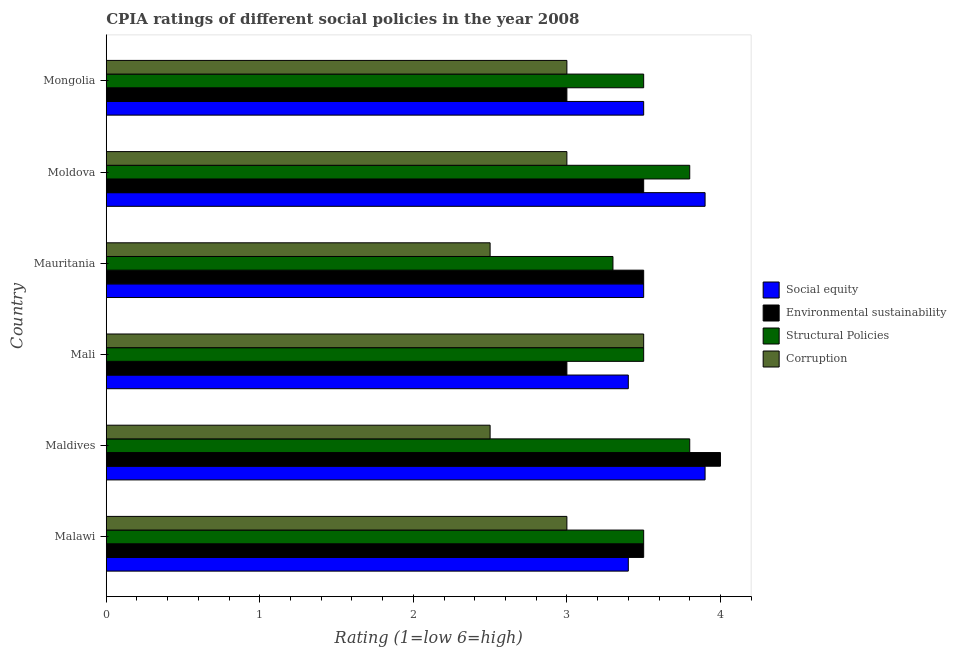How many groups of bars are there?
Provide a succinct answer. 6. Are the number of bars per tick equal to the number of legend labels?
Make the answer very short. Yes. Are the number of bars on each tick of the Y-axis equal?
Offer a very short reply. Yes. How many bars are there on the 4th tick from the top?
Provide a short and direct response. 4. How many bars are there on the 2nd tick from the bottom?
Offer a very short reply. 4. What is the label of the 6th group of bars from the top?
Provide a succinct answer. Malawi. In how many cases, is the number of bars for a given country not equal to the number of legend labels?
Make the answer very short. 0. What is the cpia rating of environmental sustainability in Malawi?
Your answer should be compact. 3.5. Across all countries, what is the maximum cpia rating of environmental sustainability?
Your response must be concise. 4. In which country was the cpia rating of structural policies maximum?
Provide a short and direct response. Maldives. In which country was the cpia rating of corruption minimum?
Your answer should be very brief. Maldives. What is the difference between the cpia rating of social equity in Mongolia and the cpia rating of environmental sustainability in Mali?
Make the answer very short. 0.5. What is the average cpia rating of structural policies per country?
Provide a short and direct response. 3.57. Is the difference between the cpia rating of social equity in Maldives and Mongolia greater than the difference between the cpia rating of environmental sustainability in Maldives and Mongolia?
Keep it short and to the point. No. What is the difference between the highest and the lowest cpia rating of environmental sustainability?
Give a very brief answer. 1. What does the 4th bar from the top in Moldova represents?
Your answer should be compact. Social equity. What does the 3rd bar from the bottom in Mongolia represents?
Keep it short and to the point. Structural Policies. How many bars are there?
Keep it short and to the point. 24. How many countries are there in the graph?
Make the answer very short. 6. Are the values on the major ticks of X-axis written in scientific E-notation?
Make the answer very short. No. Does the graph contain grids?
Ensure brevity in your answer.  No. How many legend labels are there?
Offer a terse response. 4. What is the title of the graph?
Make the answer very short. CPIA ratings of different social policies in the year 2008. Does "Gender equality" appear as one of the legend labels in the graph?
Provide a succinct answer. No. What is the Rating (1=low 6=high) in Environmental sustainability in Malawi?
Make the answer very short. 3.5. What is the Rating (1=low 6=high) of Social equity in Maldives?
Your response must be concise. 3.9. What is the Rating (1=low 6=high) in Environmental sustainability in Mauritania?
Your response must be concise. 3.5. What is the Rating (1=low 6=high) in Corruption in Mauritania?
Give a very brief answer. 2.5. What is the Rating (1=low 6=high) in Environmental sustainability in Moldova?
Make the answer very short. 3.5. What is the Rating (1=low 6=high) in Structural Policies in Moldova?
Ensure brevity in your answer.  3.8. What is the Rating (1=low 6=high) of Social equity in Mongolia?
Make the answer very short. 3.5. What is the Rating (1=low 6=high) in Environmental sustainability in Mongolia?
Keep it short and to the point. 3. What is the Rating (1=low 6=high) in Corruption in Mongolia?
Your answer should be very brief. 3. Across all countries, what is the maximum Rating (1=low 6=high) in Environmental sustainability?
Ensure brevity in your answer.  4. Across all countries, what is the maximum Rating (1=low 6=high) in Structural Policies?
Give a very brief answer. 3.8. Across all countries, what is the maximum Rating (1=low 6=high) of Corruption?
Keep it short and to the point. 3.5. Across all countries, what is the minimum Rating (1=low 6=high) in Social equity?
Offer a terse response. 3.4. What is the total Rating (1=low 6=high) in Social equity in the graph?
Ensure brevity in your answer.  21.6. What is the total Rating (1=low 6=high) in Structural Policies in the graph?
Your answer should be compact. 21.4. What is the difference between the Rating (1=low 6=high) in Social equity in Malawi and that in Maldives?
Provide a succinct answer. -0.5. What is the difference between the Rating (1=low 6=high) of Environmental sustainability in Malawi and that in Maldives?
Your answer should be very brief. -0.5. What is the difference between the Rating (1=low 6=high) of Structural Policies in Malawi and that in Maldives?
Provide a short and direct response. -0.3. What is the difference between the Rating (1=low 6=high) in Social equity in Malawi and that in Mali?
Offer a very short reply. 0. What is the difference between the Rating (1=low 6=high) of Environmental sustainability in Malawi and that in Mali?
Make the answer very short. 0.5. What is the difference between the Rating (1=low 6=high) of Structural Policies in Malawi and that in Mali?
Ensure brevity in your answer.  0. What is the difference between the Rating (1=low 6=high) of Corruption in Malawi and that in Mali?
Offer a very short reply. -0.5. What is the difference between the Rating (1=low 6=high) of Corruption in Malawi and that in Mauritania?
Offer a very short reply. 0.5. What is the difference between the Rating (1=low 6=high) of Social equity in Malawi and that in Moldova?
Provide a succinct answer. -0.5. What is the difference between the Rating (1=low 6=high) in Environmental sustainability in Malawi and that in Moldova?
Keep it short and to the point. 0. What is the difference between the Rating (1=low 6=high) in Structural Policies in Malawi and that in Moldova?
Offer a very short reply. -0.3. What is the difference between the Rating (1=low 6=high) of Social equity in Malawi and that in Mongolia?
Your response must be concise. -0.1. What is the difference between the Rating (1=low 6=high) in Corruption in Malawi and that in Mongolia?
Provide a short and direct response. 0. What is the difference between the Rating (1=low 6=high) in Social equity in Maldives and that in Mali?
Offer a terse response. 0.5. What is the difference between the Rating (1=low 6=high) in Environmental sustainability in Maldives and that in Mali?
Your answer should be very brief. 1. What is the difference between the Rating (1=low 6=high) in Corruption in Maldives and that in Mali?
Your response must be concise. -1. What is the difference between the Rating (1=low 6=high) in Social equity in Maldives and that in Mauritania?
Your answer should be compact. 0.4. What is the difference between the Rating (1=low 6=high) in Environmental sustainability in Maldives and that in Mauritania?
Keep it short and to the point. 0.5. What is the difference between the Rating (1=low 6=high) of Structural Policies in Maldives and that in Mauritania?
Make the answer very short. 0.5. What is the difference between the Rating (1=low 6=high) of Social equity in Maldives and that in Moldova?
Your answer should be very brief. 0. What is the difference between the Rating (1=low 6=high) of Environmental sustainability in Maldives and that in Moldova?
Your answer should be very brief. 0.5. What is the difference between the Rating (1=low 6=high) in Corruption in Maldives and that in Moldova?
Give a very brief answer. -0.5. What is the difference between the Rating (1=low 6=high) of Social equity in Maldives and that in Mongolia?
Give a very brief answer. 0.4. What is the difference between the Rating (1=low 6=high) in Corruption in Maldives and that in Mongolia?
Offer a very short reply. -0.5. What is the difference between the Rating (1=low 6=high) in Environmental sustainability in Mali and that in Mauritania?
Offer a very short reply. -0.5. What is the difference between the Rating (1=low 6=high) of Corruption in Mali and that in Mauritania?
Offer a terse response. 1. What is the difference between the Rating (1=low 6=high) of Social equity in Mali and that in Moldova?
Give a very brief answer. -0.5. What is the difference between the Rating (1=low 6=high) of Structural Policies in Mali and that in Moldova?
Make the answer very short. -0.3. What is the difference between the Rating (1=low 6=high) of Corruption in Mali and that in Moldova?
Your answer should be compact. 0.5. What is the difference between the Rating (1=low 6=high) of Environmental sustainability in Mali and that in Mongolia?
Offer a very short reply. 0. What is the difference between the Rating (1=low 6=high) in Structural Policies in Mali and that in Mongolia?
Make the answer very short. 0. What is the difference between the Rating (1=low 6=high) of Environmental sustainability in Mauritania and that in Moldova?
Your answer should be compact. 0. What is the difference between the Rating (1=low 6=high) of Social equity in Mauritania and that in Mongolia?
Provide a short and direct response. 0. What is the difference between the Rating (1=low 6=high) of Structural Policies in Mauritania and that in Mongolia?
Your response must be concise. -0.2. What is the difference between the Rating (1=low 6=high) in Corruption in Mauritania and that in Mongolia?
Your response must be concise. -0.5. What is the difference between the Rating (1=low 6=high) of Social equity in Moldova and that in Mongolia?
Offer a terse response. 0.4. What is the difference between the Rating (1=low 6=high) in Environmental sustainability in Moldova and that in Mongolia?
Keep it short and to the point. 0.5. What is the difference between the Rating (1=low 6=high) in Structural Policies in Moldova and that in Mongolia?
Provide a succinct answer. 0.3. What is the difference between the Rating (1=low 6=high) in Corruption in Moldova and that in Mongolia?
Ensure brevity in your answer.  0. What is the difference between the Rating (1=low 6=high) of Social equity in Malawi and the Rating (1=low 6=high) of Environmental sustainability in Maldives?
Make the answer very short. -0.6. What is the difference between the Rating (1=low 6=high) of Social equity in Malawi and the Rating (1=low 6=high) of Corruption in Maldives?
Offer a very short reply. 0.9. What is the difference between the Rating (1=low 6=high) in Environmental sustainability in Malawi and the Rating (1=low 6=high) in Structural Policies in Maldives?
Your answer should be compact. -0.3. What is the difference between the Rating (1=low 6=high) in Environmental sustainability in Malawi and the Rating (1=low 6=high) in Corruption in Maldives?
Your answer should be very brief. 1. What is the difference between the Rating (1=low 6=high) in Social equity in Malawi and the Rating (1=low 6=high) in Structural Policies in Mali?
Your answer should be very brief. -0.1. What is the difference between the Rating (1=low 6=high) of Social equity in Malawi and the Rating (1=low 6=high) of Corruption in Mali?
Your answer should be compact. -0.1. What is the difference between the Rating (1=low 6=high) of Environmental sustainability in Malawi and the Rating (1=low 6=high) of Corruption in Mali?
Make the answer very short. 0. What is the difference between the Rating (1=low 6=high) in Social equity in Malawi and the Rating (1=low 6=high) in Structural Policies in Mauritania?
Ensure brevity in your answer.  0.1. What is the difference between the Rating (1=low 6=high) in Environmental sustainability in Malawi and the Rating (1=low 6=high) in Corruption in Mauritania?
Make the answer very short. 1. What is the difference between the Rating (1=low 6=high) of Social equity in Malawi and the Rating (1=low 6=high) of Corruption in Moldova?
Give a very brief answer. 0.4. What is the difference between the Rating (1=low 6=high) of Structural Policies in Malawi and the Rating (1=low 6=high) of Corruption in Moldova?
Your response must be concise. 0.5. What is the difference between the Rating (1=low 6=high) in Social equity in Malawi and the Rating (1=low 6=high) in Corruption in Mongolia?
Keep it short and to the point. 0.4. What is the difference between the Rating (1=low 6=high) in Environmental sustainability in Malawi and the Rating (1=low 6=high) in Corruption in Mongolia?
Your answer should be very brief. 0.5. What is the difference between the Rating (1=low 6=high) in Social equity in Maldives and the Rating (1=low 6=high) in Environmental sustainability in Mali?
Make the answer very short. 0.9. What is the difference between the Rating (1=low 6=high) in Social equity in Maldives and the Rating (1=low 6=high) in Structural Policies in Mali?
Offer a terse response. 0.4. What is the difference between the Rating (1=low 6=high) of Environmental sustainability in Maldives and the Rating (1=low 6=high) of Structural Policies in Mali?
Your answer should be very brief. 0.5. What is the difference between the Rating (1=low 6=high) in Structural Policies in Maldives and the Rating (1=low 6=high) in Corruption in Mali?
Keep it short and to the point. 0.3. What is the difference between the Rating (1=low 6=high) in Environmental sustainability in Maldives and the Rating (1=low 6=high) in Corruption in Mauritania?
Your response must be concise. 1.5. What is the difference between the Rating (1=low 6=high) of Structural Policies in Maldives and the Rating (1=low 6=high) of Corruption in Mauritania?
Your answer should be very brief. 1.3. What is the difference between the Rating (1=low 6=high) in Social equity in Maldives and the Rating (1=low 6=high) in Environmental sustainability in Moldova?
Give a very brief answer. 0.4. What is the difference between the Rating (1=low 6=high) in Social equity in Maldives and the Rating (1=low 6=high) in Structural Policies in Moldova?
Offer a very short reply. 0.1. What is the difference between the Rating (1=low 6=high) in Environmental sustainability in Maldives and the Rating (1=low 6=high) in Structural Policies in Moldova?
Keep it short and to the point. 0.2. What is the difference between the Rating (1=low 6=high) of Environmental sustainability in Maldives and the Rating (1=low 6=high) of Corruption in Moldova?
Your answer should be very brief. 1. What is the difference between the Rating (1=low 6=high) of Social equity in Maldives and the Rating (1=low 6=high) of Environmental sustainability in Mongolia?
Your answer should be compact. 0.9. What is the difference between the Rating (1=low 6=high) in Environmental sustainability in Maldives and the Rating (1=low 6=high) in Structural Policies in Mongolia?
Keep it short and to the point. 0.5. What is the difference between the Rating (1=low 6=high) of Structural Policies in Maldives and the Rating (1=low 6=high) of Corruption in Mongolia?
Your answer should be compact. 0.8. What is the difference between the Rating (1=low 6=high) in Social equity in Mali and the Rating (1=low 6=high) in Environmental sustainability in Mauritania?
Offer a very short reply. -0.1. What is the difference between the Rating (1=low 6=high) in Social equity in Mali and the Rating (1=low 6=high) in Structural Policies in Mauritania?
Your response must be concise. 0.1. What is the difference between the Rating (1=low 6=high) of Environmental sustainability in Mali and the Rating (1=low 6=high) of Corruption in Mauritania?
Make the answer very short. 0.5. What is the difference between the Rating (1=low 6=high) in Structural Policies in Mali and the Rating (1=low 6=high) in Corruption in Mauritania?
Your answer should be very brief. 1. What is the difference between the Rating (1=low 6=high) of Social equity in Mali and the Rating (1=low 6=high) of Environmental sustainability in Moldova?
Keep it short and to the point. -0.1. What is the difference between the Rating (1=low 6=high) in Environmental sustainability in Mali and the Rating (1=low 6=high) in Corruption in Moldova?
Make the answer very short. 0. What is the difference between the Rating (1=low 6=high) in Structural Policies in Mali and the Rating (1=low 6=high) in Corruption in Moldova?
Your response must be concise. 0.5. What is the difference between the Rating (1=low 6=high) in Social equity in Mali and the Rating (1=low 6=high) in Environmental sustainability in Mongolia?
Provide a succinct answer. 0.4. What is the difference between the Rating (1=low 6=high) of Social equity in Mali and the Rating (1=low 6=high) of Structural Policies in Mongolia?
Ensure brevity in your answer.  -0.1. What is the difference between the Rating (1=low 6=high) in Environmental sustainability in Mali and the Rating (1=low 6=high) in Corruption in Mongolia?
Give a very brief answer. 0. What is the difference between the Rating (1=low 6=high) in Social equity in Mauritania and the Rating (1=low 6=high) in Structural Policies in Moldova?
Make the answer very short. -0.3. What is the difference between the Rating (1=low 6=high) of Social equity in Mauritania and the Rating (1=low 6=high) of Corruption in Moldova?
Give a very brief answer. 0.5. What is the difference between the Rating (1=low 6=high) of Environmental sustainability in Mauritania and the Rating (1=low 6=high) of Corruption in Moldova?
Provide a short and direct response. 0.5. What is the difference between the Rating (1=low 6=high) of Social equity in Mauritania and the Rating (1=low 6=high) of Structural Policies in Mongolia?
Your response must be concise. 0. What is the difference between the Rating (1=low 6=high) in Social equity in Mauritania and the Rating (1=low 6=high) in Corruption in Mongolia?
Ensure brevity in your answer.  0.5. What is the difference between the Rating (1=low 6=high) in Environmental sustainability in Mauritania and the Rating (1=low 6=high) in Structural Policies in Mongolia?
Provide a short and direct response. 0. What is the difference between the Rating (1=low 6=high) in Social equity in Moldova and the Rating (1=low 6=high) in Environmental sustainability in Mongolia?
Offer a terse response. 0.9. What is the difference between the Rating (1=low 6=high) in Structural Policies in Moldova and the Rating (1=low 6=high) in Corruption in Mongolia?
Offer a terse response. 0.8. What is the average Rating (1=low 6=high) of Environmental sustainability per country?
Your response must be concise. 3.42. What is the average Rating (1=low 6=high) in Structural Policies per country?
Keep it short and to the point. 3.57. What is the average Rating (1=low 6=high) in Corruption per country?
Offer a very short reply. 2.92. What is the difference between the Rating (1=low 6=high) of Social equity and Rating (1=low 6=high) of Environmental sustainability in Malawi?
Ensure brevity in your answer.  -0.1. What is the difference between the Rating (1=low 6=high) of Social equity and Rating (1=low 6=high) of Structural Policies in Malawi?
Make the answer very short. -0.1. What is the difference between the Rating (1=low 6=high) in Structural Policies and Rating (1=low 6=high) in Corruption in Malawi?
Provide a succinct answer. 0.5. What is the difference between the Rating (1=low 6=high) of Social equity and Rating (1=low 6=high) of Environmental sustainability in Maldives?
Your answer should be compact. -0.1. What is the difference between the Rating (1=low 6=high) in Social equity and Rating (1=low 6=high) in Structural Policies in Maldives?
Offer a very short reply. 0.1. What is the difference between the Rating (1=low 6=high) in Social equity and Rating (1=low 6=high) in Corruption in Maldives?
Offer a very short reply. 1.4. What is the difference between the Rating (1=low 6=high) of Social equity and Rating (1=low 6=high) of Structural Policies in Mali?
Offer a very short reply. -0.1. What is the difference between the Rating (1=low 6=high) in Social equity and Rating (1=low 6=high) in Corruption in Mali?
Your answer should be compact. -0.1. What is the difference between the Rating (1=low 6=high) in Environmental sustainability and Rating (1=low 6=high) in Structural Policies in Mali?
Keep it short and to the point. -0.5. What is the difference between the Rating (1=low 6=high) of Environmental sustainability and Rating (1=low 6=high) of Structural Policies in Mauritania?
Keep it short and to the point. 0.2. What is the difference between the Rating (1=low 6=high) of Structural Policies and Rating (1=low 6=high) of Corruption in Mauritania?
Ensure brevity in your answer.  0.8. What is the difference between the Rating (1=low 6=high) in Social equity and Rating (1=low 6=high) in Structural Policies in Moldova?
Keep it short and to the point. 0.1. What is the difference between the Rating (1=low 6=high) of Social equity and Rating (1=low 6=high) of Corruption in Moldova?
Your answer should be compact. 0.9. What is the difference between the Rating (1=low 6=high) of Environmental sustainability and Rating (1=low 6=high) of Structural Policies in Moldova?
Your answer should be compact. -0.3. What is the difference between the Rating (1=low 6=high) of Environmental sustainability and Rating (1=low 6=high) of Corruption in Moldova?
Give a very brief answer. 0.5. What is the difference between the Rating (1=low 6=high) in Structural Policies and Rating (1=low 6=high) in Corruption in Moldova?
Provide a succinct answer. 0.8. What is the difference between the Rating (1=low 6=high) in Social equity and Rating (1=low 6=high) in Structural Policies in Mongolia?
Offer a terse response. 0. What is the difference between the Rating (1=low 6=high) in Environmental sustainability and Rating (1=low 6=high) in Corruption in Mongolia?
Provide a succinct answer. 0. What is the ratio of the Rating (1=low 6=high) of Social equity in Malawi to that in Maldives?
Give a very brief answer. 0.87. What is the ratio of the Rating (1=low 6=high) in Environmental sustainability in Malawi to that in Maldives?
Your answer should be very brief. 0.88. What is the ratio of the Rating (1=low 6=high) of Structural Policies in Malawi to that in Maldives?
Offer a terse response. 0.92. What is the ratio of the Rating (1=low 6=high) in Social equity in Malawi to that in Mali?
Ensure brevity in your answer.  1. What is the ratio of the Rating (1=low 6=high) in Structural Policies in Malawi to that in Mali?
Your answer should be compact. 1. What is the ratio of the Rating (1=low 6=high) in Corruption in Malawi to that in Mali?
Your answer should be very brief. 0.86. What is the ratio of the Rating (1=low 6=high) of Social equity in Malawi to that in Mauritania?
Offer a very short reply. 0.97. What is the ratio of the Rating (1=low 6=high) of Structural Policies in Malawi to that in Mauritania?
Offer a terse response. 1.06. What is the ratio of the Rating (1=low 6=high) of Social equity in Malawi to that in Moldova?
Offer a very short reply. 0.87. What is the ratio of the Rating (1=low 6=high) in Environmental sustainability in Malawi to that in Moldova?
Your answer should be very brief. 1. What is the ratio of the Rating (1=low 6=high) in Structural Policies in Malawi to that in Moldova?
Your answer should be compact. 0.92. What is the ratio of the Rating (1=low 6=high) of Corruption in Malawi to that in Moldova?
Ensure brevity in your answer.  1. What is the ratio of the Rating (1=low 6=high) of Social equity in Malawi to that in Mongolia?
Keep it short and to the point. 0.97. What is the ratio of the Rating (1=low 6=high) in Corruption in Malawi to that in Mongolia?
Offer a terse response. 1. What is the ratio of the Rating (1=low 6=high) in Social equity in Maldives to that in Mali?
Keep it short and to the point. 1.15. What is the ratio of the Rating (1=low 6=high) in Environmental sustainability in Maldives to that in Mali?
Ensure brevity in your answer.  1.33. What is the ratio of the Rating (1=low 6=high) in Structural Policies in Maldives to that in Mali?
Make the answer very short. 1.09. What is the ratio of the Rating (1=low 6=high) of Corruption in Maldives to that in Mali?
Offer a terse response. 0.71. What is the ratio of the Rating (1=low 6=high) of Social equity in Maldives to that in Mauritania?
Provide a succinct answer. 1.11. What is the ratio of the Rating (1=low 6=high) in Environmental sustainability in Maldives to that in Mauritania?
Your answer should be very brief. 1.14. What is the ratio of the Rating (1=low 6=high) of Structural Policies in Maldives to that in Mauritania?
Ensure brevity in your answer.  1.15. What is the ratio of the Rating (1=low 6=high) of Environmental sustainability in Maldives to that in Moldova?
Provide a succinct answer. 1.14. What is the ratio of the Rating (1=low 6=high) in Structural Policies in Maldives to that in Moldova?
Offer a terse response. 1. What is the ratio of the Rating (1=low 6=high) of Social equity in Maldives to that in Mongolia?
Ensure brevity in your answer.  1.11. What is the ratio of the Rating (1=low 6=high) of Environmental sustainability in Maldives to that in Mongolia?
Offer a very short reply. 1.33. What is the ratio of the Rating (1=low 6=high) of Structural Policies in Maldives to that in Mongolia?
Your response must be concise. 1.09. What is the ratio of the Rating (1=low 6=high) in Social equity in Mali to that in Mauritania?
Keep it short and to the point. 0.97. What is the ratio of the Rating (1=low 6=high) in Environmental sustainability in Mali to that in Mauritania?
Keep it short and to the point. 0.86. What is the ratio of the Rating (1=low 6=high) in Structural Policies in Mali to that in Mauritania?
Keep it short and to the point. 1.06. What is the ratio of the Rating (1=low 6=high) of Social equity in Mali to that in Moldova?
Your answer should be very brief. 0.87. What is the ratio of the Rating (1=low 6=high) of Structural Policies in Mali to that in Moldova?
Give a very brief answer. 0.92. What is the ratio of the Rating (1=low 6=high) of Corruption in Mali to that in Moldova?
Make the answer very short. 1.17. What is the ratio of the Rating (1=low 6=high) of Social equity in Mali to that in Mongolia?
Provide a succinct answer. 0.97. What is the ratio of the Rating (1=low 6=high) in Corruption in Mali to that in Mongolia?
Offer a terse response. 1.17. What is the ratio of the Rating (1=low 6=high) of Social equity in Mauritania to that in Moldova?
Your answer should be very brief. 0.9. What is the ratio of the Rating (1=low 6=high) of Structural Policies in Mauritania to that in Moldova?
Provide a short and direct response. 0.87. What is the ratio of the Rating (1=low 6=high) of Corruption in Mauritania to that in Moldova?
Your answer should be very brief. 0.83. What is the ratio of the Rating (1=low 6=high) in Social equity in Mauritania to that in Mongolia?
Keep it short and to the point. 1. What is the ratio of the Rating (1=low 6=high) of Structural Policies in Mauritania to that in Mongolia?
Provide a succinct answer. 0.94. What is the ratio of the Rating (1=low 6=high) in Corruption in Mauritania to that in Mongolia?
Your response must be concise. 0.83. What is the ratio of the Rating (1=low 6=high) of Social equity in Moldova to that in Mongolia?
Your answer should be compact. 1.11. What is the ratio of the Rating (1=low 6=high) in Environmental sustainability in Moldova to that in Mongolia?
Provide a short and direct response. 1.17. What is the ratio of the Rating (1=low 6=high) in Structural Policies in Moldova to that in Mongolia?
Ensure brevity in your answer.  1.09. What is the ratio of the Rating (1=low 6=high) of Corruption in Moldova to that in Mongolia?
Your answer should be very brief. 1. What is the difference between the highest and the second highest Rating (1=low 6=high) in Social equity?
Offer a very short reply. 0. What is the difference between the highest and the second highest Rating (1=low 6=high) in Environmental sustainability?
Ensure brevity in your answer.  0.5. What is the difference between the highest and the second highest Rating (1=low 6=high) in Structural Policies?
Offer a terse response. 0. What is the difference between the highest and the second highest Rating (1=low 6=high) of Corruption?
Give a very brief answer. 0.5. What is the difference between the highest and the lowest Rating (1=low 6=high) of Social equity?
Keep it short and to the point. 0.5. What is the difference between the highest and the lowest Rating (1=low 6=high) in Structural Policies?
Your answer should be compact. 0.5. 